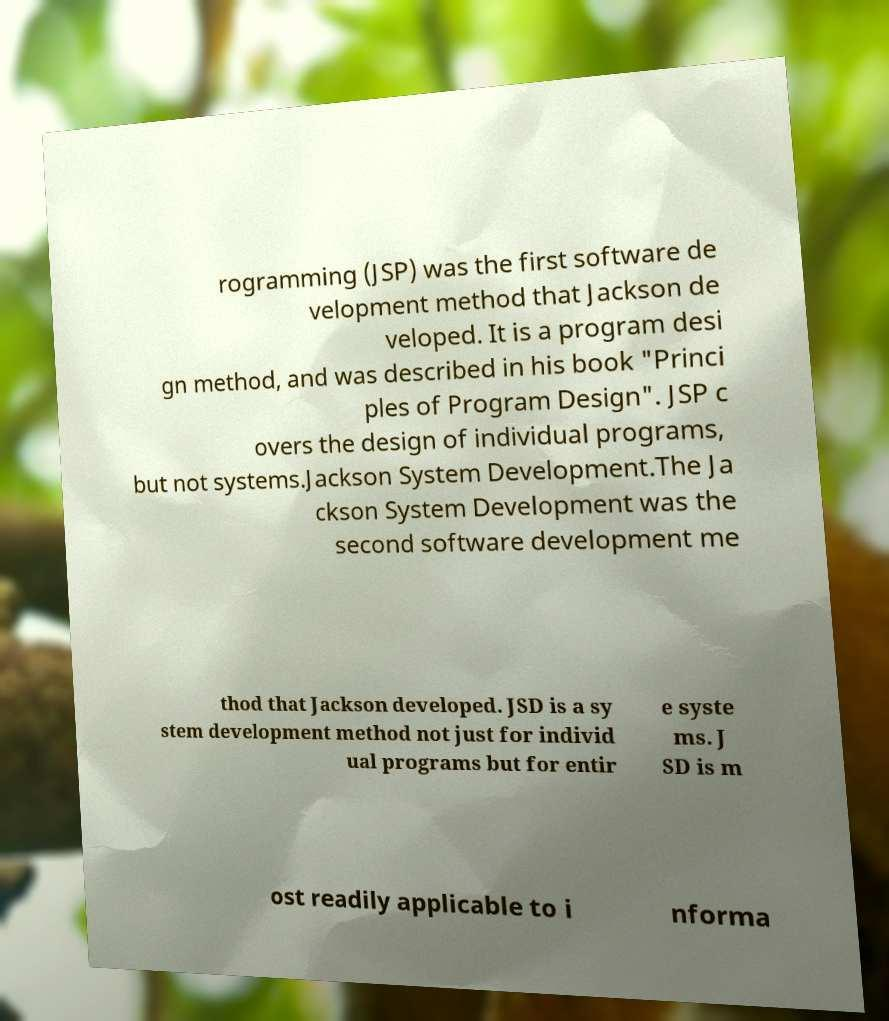Please identify and transcribe the text found in this image. rogramming (JSP) was the first software de velopment method that Jackson de veloped. It is a program desi gn method, and was described in his book "Princi ples of Program Design". JSP c overs the design of individual programs, but not systems.Jackson System Development.The Ja ckson System Development was the second software development me thod that Jackson developed. JSD is a sy stem development method not just for individ ual programs but for entir e syste ms. J SD is m ost readily applicable to i nforma 